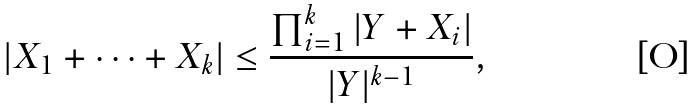Convert formula to latex. <formula><loc_0><loc_0><loc_500><loc_500>| X _ { 1 } + \dots + X _ { k } | \leq \frac { \prod _ { i = 1 } ^ { k } | Y + X _ { i } | } { | Y | ^ { k - 1 } } ,</formula> 